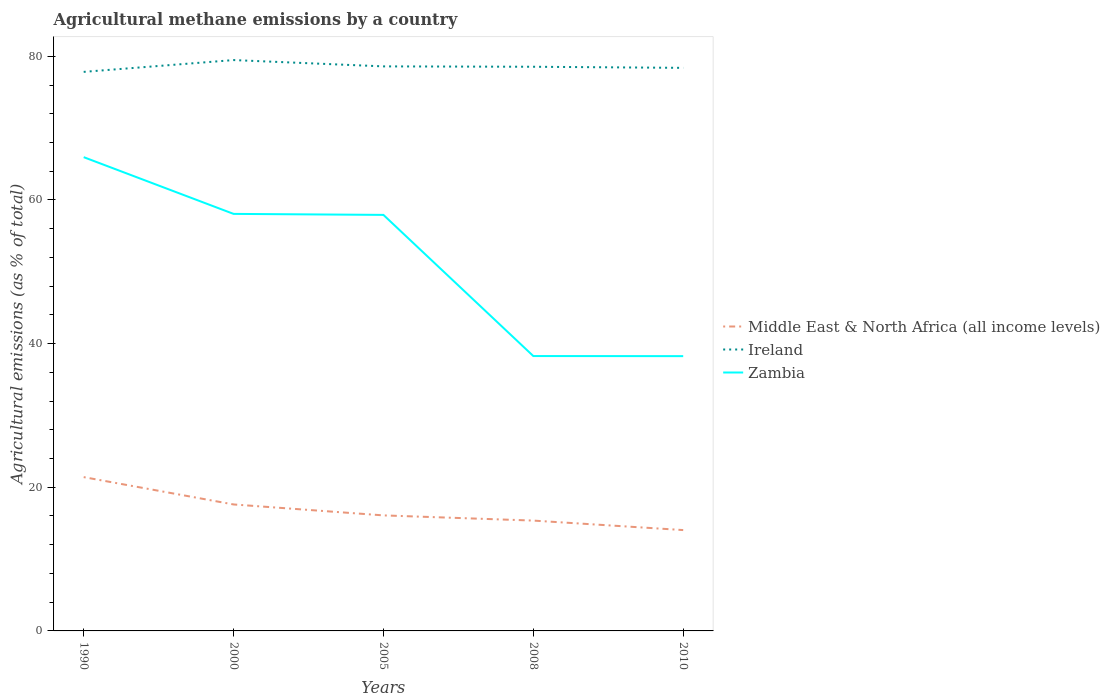How many different coloured lines are there?
Keep it short and to the point. 3. Does the line corresponding to Middle East & North Africa (all income levels) intersect with the line corresponding to Zambia?
Give a very brief answer. No. Is the number of lines equal to the number of legend labels?
Keep it short and to the point. Yes. Across all years, what is the maximum amount of agricultural methane emitted in Ireland?
Your answer should be compact. 77.83. What is the total amount of agricultural methane emitted in Middle East & North Africa (all income levels) in the graph?
Provide a succinct answer. 6.05. What is the difference between the highest and the second highest amount of agricultural methane emitted in Zambia?
Make the answer very short. 27.7. Are the values on the major ticks of Y-axis written in scientific E-notation?
Ensure brevity in your answer.  No. Does the graph contain any zero values?
Your answer should be very brief. No. How many legend labels are there?
Ensure brevity in your answer.  3. What is the title of the graph?
Provide a succinct answer. Agricultural methane emissions by a country. What is the label or title of the Y-axis?
Your answer should be compact. Agricultural emissions (as % of total). What is the Agricultural emissions (as % of total) of Middle East & North Africa (all income levels) in 1990?
Provide a short and direct response. 21.41. What is the Agricultural emissions (as % of total) of Ireland in 1990?
Keep it short and to the point. 77.83. What is the Agricultural emissions (as % of total) in Zambia in 1990?
Make the answer very short. 65.96. What is the Agricultural emissions (as % of total) in Middle East & North Africa (all income levels) in 2000?
Give a very brief answer. 17.61. What is the Agricultural emissions (as % of total) of Ireland in 2000?
Keep it short and to the point. 79.48. What is the Agricultural emissions (as % of total) of Zambia in 2000?
Give a very brief answer. 58.06. What is the Agricultural emissions (as % of total) of Middle East & North Africa (all income levels) in 2005?
Offer a very short reply. 16.09. What is the Agricultural emissions (as % of total) of Ireland in 2005?
Your answer should be very brief. 78.6. What is the Agricultural emissions (as % of total) of Zambia in 2005?
Ensure brevity in your answer.  57.92. What is the Agricultural emissions (as % of total) in Middle East & North Africa (all income levels) in 2008?
Ensure brevity in your answer.  15.36. What is the Agricultural emissions (as % of total) of Ireland in 2008?
Offer a terse response. 78.55. What is the Agricultural emissions (as % of total) of Zambia in 2008?
Your answer should be very brief. 38.27. What is the Agricultural emissions (as % of total) in Middle East & North Africa (all income levels) in 2010?
Your answer should be compact. 14.04. What is the Agricultural emissions (as % of total) of Ireland in 2010?
Make the answer very short. 78.39. What is the Agricultural emissions (as % of total) in Zambia in 2010?
Keep it short and to the point. 38.26. Across all years, what is the maximum Agricultural emissions (as % of total) in Middle East & North Africa (all income levels)?
Your answer should be very brief. 21.41. Across all years, what is the maximum Agricultural emissions (as % of total) of Ireland?
Your answer should be compact. 79.48. Across all years, what is the maximum Agricultural emissions (as % of total) of Zambia?
Offer a terse response. 65.96. Across all years, what is the minimum Agricultural emissions (as % of total) of Middle East & North Africa (all income levels)?
Provide a short and direct response. 14.04. Across all years, what is the minimum Agricultural emissions (as % of total) of Ireland?
Make the answer very short. 77.83. Across all years, what is the minimum Agricultural emissions (as % of total) in Zambia?
Your answer should be compact. 38.26. What is the total Agricultural emissions (as % of total) in Middle East & North Africa (all income levels) in the graph?
Provide a short and direct response. 84.51. What is the total Agricultural emissions (as % of total) of Ireland in the graph?
Provide a succinct answer. 392.85. What is the total Agricultural emissions (as % of total) of Zambia in the graph?
Offer a terse response. 258.47. What is the difference between the Agricultural emissions (as % of total) of Middle East & North Africa (all income levels) in 1990 and that in 2000?
Keep it short and to the point. 3.81. What is the difference between the Agricultural emissions (as % of total) in Ireland in 1990 and that in 2000?
Offer a very short reply. -1.64. What is the difference between the Agricultural emissions (as % of total) of Zambia in 1990 and that in 2000?
Keep it short and to the point. 7.9. What is the difference between the Agricultural emissions (as % of total) of Middle East & North Africa (all income levels) in 1990 and that in 2005?
Your answer should be very brief. 5.33. What is the difference between the Agricultural emissions (as % of total) in Ireland in 1990 and that in 2005?
Your answer should be very brief. -0.76. What is the difference between the Agricultural emissions (as % of total) of Zambia in 1990 and that in 2005?
Keep it short and to the point. 8.04. What is the difference between the Agricultural emissions (as % of total) of Middle East & North Africa (all income levels) in 1990 and that in 2008?
Provide a short and direct response. 6.05. What is the difference between the Agricultural emissions (as % of total) of Ireland in 1990 and that in 2008?
Provide a short and direct response. -0.71. What is the difference between the Agricultural emissions (as % of total) of Zambia in 1990 and that in 2008?
Offer a very short reply. 27.69. What is the difference between the Agricultural emissions (as % of total) in Middle East & North Africa (all income levels) in 1990 and that in 2010?
Your answer should be very brief. 7.37. What is the difference between the Agricultural emissions (as % of total) in Ireland in 1990 and that in 2010?
Provide a succinct answer. -0.56. What is the difference between the Agricultural emissions (as % of total) in Zambia in 1990 and that in 2010?
Make the answer very short. 27.7. What is the difference between the Agricultural emissions (as % of total) in Middle East & North Africa (all income levels) in 2000 and that in 2005?
Give a very brief answer. 1.52. What is the difference between the Agricultural emissions (as % of total) of Ireland in 2000 and that in 2005?
Offer a very short reply. 0.88. What is the difference between the Agricultural emissions (as % of total) of Zambia in 2000 and that in 2005?
Offer a very short reply. 0.14. What is the difference between the Agricultural emissions (as % of total) in Middle East & North Africa (all income levels) in 2000 and that in 2008?
Provide a short and direct response. 2.25. What is the difference between the Agricultural emissions (as % of total) in Ireland in 2000 and that in 2008?
Your answer should be compact. 0.93. What is the difference between the Agricultural emissions (as % of total) in Zambia in 2000 and that in 2008?
Your answer should be very brief. 19.79. What is the difference between the Agricultural emissions (as % of total) of Middle East & North Africa (all income levels) in 2000 and that in 2010?
Offer a terse response. 3.57. What is the difference between the Agricultural emissions (as % of total) of Ireland in 2000 and that in 2010?
Your answer should be compact. 1.08. What is the difference between the Agricultural emissions (as % of total) of Zambia in 2000 and that in 2010?
Your answer should be compact. 19.8. What is the difference between the Agricultural emissions (as % of total) in Middle East & North Africa (all income levels) in 2005 and that in 2008?
Your answer should be compact. 0.72. What is the difference between the Agricultural emissions (as % of total) in Ireland in 2005 and that in 2008?
Your answer should be compact. 0.05. What is the difference between the Agricultural emissions (as % of total) in Zambia in 2005 and that in 2008?
Keep it short and to the point. 19.65. What is the difference between the Agricultural emissions (as % of total) in Middle East & North Africa (all income levels) in 2005 and that in 2010?
Provide a short and direct response. 2.05. What is the difference between the Agricultural emissions (as % of total) in Ireland in 2005 and that in 2010?
Provide a succinct answer. 0.21. What is the difference between the Agricultural emissions (as % of total) in Zambia in 2005 and that in 2010?
Keep it short and to the point. 19.66. What is the difference between the Agricultural emissions (as % of total) of Middle East & North Africa (all income levels) in 2008 and that in 2010?
Make the answer very short. 1.32. What is the difference between the Agricultural emissions (as % of total) in Ireland in 2008 and that in 2010?
Give a very brief answer. 0.15. What is the difference between the Agricultural emissions (as % of total) of Zambia in 2008 and that in 2010?
Offer a terse response. 0.01. What is the difference between the Agricultural emissions (as % of total) in Middle East & North Africa (all income levels) in 1990 and the Agricultural emissions (as % of total) in Ireland in 2000?
Your answer should be compact. -58.06. What is the difference between the Agricultural emissions (as % of total) of Middle East & North Africa (all income levels) in 1990 and the Agricultural emissions (as % of total) of Zambia in 2000?
Offer a very short reply. -36.65. What is the difference between the Agricultural emissions (as % of total) of Ireland in 1990 and the Agricultural emissions (as % of total) of Zambia in 2000?
Your answer should be compact. 19.77. What is the difference between the Agricultural emissions (as % of total) in Middle East & North Africa (all income levels) in 1990 and the Agricultural emissions (as % of total) in Ireland in 2005?
Ensure brevity in your answer.  -57.19. What is the difference between the Agricultural emissions (as % of total) in Middle East & North Africa (all income levels) in 1990 and the Agricultural emissions (as % of total) in Zambia in 2005?
Provide a succinct answer. -36.51. What is the difference between the Agricultural emissions (as % of total) in Ireland in 1990 and the Agricultural emissions (as % of total) in Zambia in 2005?
Give a very brief answer. 19.91. What is the difference between the Agricultural emissions (as % of total) in Middle East & North Africa (all income levels) in 1990 and the Agricultural emissions (as % of total) in Ireland in 2008?
Offer a very short reply. -57.13. What is the difference between the Agricultural emissions (as % of total) in Middle East & North Africa (all income levels) in 1990 and the Agricultural emissions (as % of total) in Zambia in 2008?
Provide a succinct answer. -16.86. What is the difference between the Agricultural emissions (as % of total) of Ireland in 1990 and the Agricultural emissions (as % of total) of Zambia in 2008?
Make the answer very short. 39.57. What is the difference between the Agricultural emissions (as % of total) of Middle East & North Africa (all income levels) in 1990 and the Agricultural emissions (as % of total) of Ireland in 2010?
Your answer should be very brief. -56.98. What is the difference between the Agricultural emissions (as % of total) in Middle East & North Africa (all income levels) in 1990 and the Agricultural emissions (as % of total) in Zambia in 2010?
Make the answer very short. -16.84. What is the difference between the Agricultural emissions (as % of total) in Ireland in 1990 and the Agricultural emissions (as % of total) in Zambia in 2010?
Provide a succinct answer. 39.58. What is the difference between the Agricultural emissions (as % of total) of Middle East & North Africa (all income levels) in 2000 and the Agricultural emissions (as % of total) of Ireland in 2005?
Offer a very short reply. -60.99. What is the difference between the Agricultural emissions (as % of total) in Middle East & North Africa (all income levels) in 2000 and the Agricultural emissions (as % of total) in Zambia in 2005?
Give a very brief answer. -40.31. What is the difference between the Agricultural emissions (as % of total) of Ireland in 2000 and the Agricultural emissions (as % of total) of Zambia in 2005?
Offer a terse response. 21.55. What is the difference between the Agricultural emissions (as % of total) of Middle East & North Africa (all income levels) in 2000 and the Agricultural emissions (as % of total) of Ireland in 2008?
Offer a very short reply. -60.94. What is the difference between the Agricultural emissions (as % of total) of Middle East & North Africa (all income levels) in 2000 and the Agricultural emissions (as % of total) of Zambia in 2008?
Give a very brief answer. -20.66. What is the difference between the Agricultural emissions (as % of total) in Ireland in 2000 and the Agricultural emissions (as % of total) in Zambia in 2008?
Make the answer very short. 41.21. What is the difference between the Agricultural emissions (as % of total) in Middle East & North Africa (all income levels) in 2000 and the Agricultural emissions (as % of total) in Ireland in 2010?
Offer a terse response. -60.78. What is the difference between the Agricultural emissions (as % of total) in Middle East & North Africa (all income levels) in 2000 and the Agricultural emissions (as % of total) in Zambia in 2010?
Your answer should be very brief. -20.65. What is the difference between the Agricultural emissions (as % of total) of Ireland in 2000 and the Agricultural emissions (as % of total) of Zambia in 2010?
Your response must be concise. 41.22. What is the difference between the Agricultural emissions (as % of total) of Middle East & North Africa (all income levels) in 2005 and the Agricultural emissions (as % of total) of Ireland in 2008?
Your answer should be very brief. -62.46. What is the difference between the Agricultural emissions (as % of total) of Middle East & North Africa (all income levels) in 2005 and the Agricultural emissions (as % of total) of Zambia in 2008?
Provide a short and direct response. -22.18. What is the difference between the Agricultural emissions (as % of total) in Ireland in 2005 and the Agricultural emissions (as % of total) in Zambia in 2008?
Offer a very short reply. 40.33. What is the difference between the Agricultural emissions (as % of total) of Middle East & North Africa (all income levels) in 2005 and the Agricultural emissions (as % of total) of Ireland in 2010?
Provide a succinct answer. -62.31. What is the difference between the Agricultural emissions (as % of total) in Middle East & North Africa (all income levels) in 2005 and the Agricultural emissions (as % of total) in Zambia in 2010?
Provide a succinct answer. -22.17. What is the difference between the Agricultural emissions (as % of total) of Ireland in 2005 and the Agricultural emissions (as % of total) of Zambia in 2010?
Make the answer very short. 40.34. What is the difference between the Agricultural emissions (as % of total) of Middle East & North Africa (all income levels) in 2008 and the Agricultural emissions (as % of total) of Ireland in 2010?
Provide a short and direct response. -63.03. What is the difference between the Agricultural emissions (as % of total) in Middle East & North Africa (all income levels) in 2008 and the Agricultural emissions (as % of total) in Zambia in 2010?
Give a very brief answer. -22.9. What is the difference between the Agricultural emissions (as % of total) in Ireland in 2008 and the Agricultural emissions (as % of total) in Zambia in 2010?
Your answer should be compact. 40.29. What is the average Agricultural emissions (as % of total) in Middle East & North Africa (all income levels) per year?
Keep it short and to the point. 16.9. What is the average Agricultural emissions (as % of total) of Ireland per year?
Provide a succinct answer. 78.57. What is the average Agricultural emissions (as % of total) of Zambia per year?
Your answer should be very brief. 51.69. In the year 1990, what is the difference between the Agricultural emissions (as % of total) in Middle East & North Africa (all income levels) and Agricultural emissions (as % of total) in Ireland?
Provide a short and direct response. -56.42. In the year 1990, what is the difference between the Agricultural emissions (as % of total) in Middle East & North Africa (all income levels) and Agricultural emissions (as % of total) in Zambia?
Your answer should be very brief. -44.55. In the year 1990, what is the difference between the Agricultural emissions (as % of total) of Ireland and Agricultural emissions (as % of total) of Zambia?
Your response must be concise. 11.87. In the year 2000, what is the difference between the Agricultural emissions (as % of total) in Middle East & North Africa (all income levels) and Agricultural emissions (as % of total) in Ireland?
Your response must be concise. -61.87. In the year 2000, what is the difference between the Agricultural emissions (as % of total) in Middle East & North Africa (all income levels) and Agricultural emissions (as % of total) in Zambia?
Provide a succinct answer. -40.45. In the year 2000, what is the difference between the Agricultural emissions (as % of total) of Ireland and Agricultural emissions (as % of total) of Zambia?
Your answer should be compact. 21.42. In the year 2005, what is the difference between the Agricultural emissions (as % of total) of Middle East & North Africa (all income levels) and Agricultural emissions (as % of total) of Ireland?
Your answer should be compact. -62.51. In the year 2005, what is the difference between the Agricultural emissions (as % of total) of Middle East & North Africa (all income levels) and Agricultural emissions (as % of total) of Zambia?
Your response must be concise. -41.84. In the year 2005, what is the difference between the Agricultural emissions (as % of total) of Ireland and Agricultural emissions (as % of total) of Zambia?
Provide a short and direct response. 20.68. In the year 2008, what is the difference between the Agricultural emissions (as % of total) of Middle East & North Africa (all income levels) and Agricultural emissions (as % of total) of Ireland?
Make the answer very short. -63.18. In the year 2008, what is the difference between the Agricultural emissions (as % of total) in Middle East & North Africa (all income levels) and Agricultural emissions (as % of total) in Zambia?
Give a very brief answer. -22.91. In the year 2008, what is the difference between the Agricultural emissions (as % of total) of Ireland and Agricultural emissions (as % of total) of Zambia?
Your response must be concise. 40.28. In the year 2010, what is the difference between the Agricultural emissions (as % of total) in Middle East & North Africa (all income levels) and Agricultural emissions (as % of total) in Ireland?
Your answer should be very brief. -64.35. In the year 2010, what is the difference between the Agricultural emissions (as % of total) in Middle East & North Africa (all income levels) and Agricultural emissions (as % of total) in Zambia?
Your answer should be very brief. -24.22. In the year 2010, what is the difference between the Agricultural emissions (as % of total) of Ireland and Agricultural emissions (as % of total) of Zambia?
Offer a very short reply. 40.14. What is the ratio of the Agricultural emissions (as % of total) of Middle East & North Africa (all income levels) in 1990 to that in 2000?
Your answer should be very brief. 1.22. What is the ratio of the Agricultural emissions (as % of total) of Ireland in 1990 to that in 2000?
Offer a terse response. 0.98. What is the ratio of the Agricultural emissions (as % of total) of Zambia in 1990 to that in 2000?
Provide a short and direct response. 1.14. What is the ratio of the Agricultural emissions (as % of total) in Middle East & North Africa (all income levels) in 1990 to that in 2005?
Make the answer very short. 1.33. What is the ratio of the Agricultural emissions (as % of total) in Ireland in 1990 to that in 2005?
Offer a terse response. 0.99. What is the ratio of the Agricultural emissions (as % of total) of Zambia in 1990 to that in 2005?
Your response must be concise. 1.14. What is the ratio of the Agricultural emissions (as % of total) in Middle East & North Africa (all income levels) in 1990 to that in 2008?
Your answer should be very brief. 1.39. What is the ratio of the Agricultural emissions (as % of total) of Ireland in 1990 to that in 2008?
Provide a succinct answer. 0.99. What is the ratio of the Agricultural emissions (as % of total) in Zambia in 1990 to that in 2008?
Offer a very short reply. 1.72. What is the ratio of the Agricultural emissions (as % of total) of Middle East & North Africa (all income levels) in 1990 to that in 2010?
Ensure brevity in your answer.  1.53. What is the ratio of the Agricultural emissions (as % of total) in Ireland in 1990 to that in 2010?
Give a very brief answer. 0.99. What is the ratio of the Agricultural emissions (as % of total) in Zambia in 1990 to that in 2010?
Your answer should be very brief. 1.72. What is the ratio of the Agricultural emissions (as % of total) in Middle East & North Africa (all income levels) in 2000 to that in 2005?
Keep it short and to the point. 1.09. What is the ratio of the Agricultural emissions (as % of total) in Ireland in 2000 to that in 2005?
Provide a short and direct response. 1.01. What is the ratio of the Agricultural emissions (as % of total) in Middle East & North Africa (all income levels) in 2000 to that in 2008?
Your answer should be compact. 1.15. What is the ratio of the Agricultural emissions (as % of total) in Ireland in 2000 to that in 2008?
Offer a very short reply. 1.01. What is the ratio of the Agricultural emissions (as % of total) of Zambia in 2000 to that in 2008?
Your response must be concise. 1.52. What is the ratio of the Agricultural emissions (as % of total) in Middle East & North Africa (all income levels) in 2000 to that in 2010?
Ensure brevity in your answer.  1.25. What is the ratio of the Agricultural emissions (as % of total) in Ireland in 2000 to that in 2010?
Make the answer very short. 1.01. What is the ratio of the Agricultural emissions (as % of total) of Zambia in 2000 to that in 2010?
Offer a very short reply. 1.52. What is the ratio of the Agricultural emissions (as % of total) in Middle East & North Africa (all income levels) in 2005 to that in 2008?
Keep it short and to the point. 1.05. What is the ratio of the Agricultural emissions (as % of total) in Ireland in 2005 to that in 2008?
Your response must be concise. 1. What is the ratio of the Agricultural emissions (as % of total) of Zambia in 2005 to that in 2008?
Provide a short and direct response. 1.51. What is the ratio of the Agricultural emissions (as % of total) of Middle East & North Africa (all income levels) in 2005 to that in 2010?
Provide a short and direct response. 1.15. What is the ratio of the Agricultural emissions (as % of total) in Zambia in 2005 to that in 2010?
Ensure brevity in your answer.  1.51. What is the ratio of the Agricultural emissions (as % of total) in Middle East & North Africa (all income levels) in 2008 to that in 2010?
Your answer should be very brief. 1.09. What is the difference between the highest and the second highest Agricultural emissions (as % of total) in Middle East & North Africa (all income levels)?
Make the answer very short. 3.81. What is the difference between the highest and the second highest Agricultural emissions (as % of total) in Ireland?
Your answer should be compact. 0.88. What is the difference between the highest and the second highest Agricultural emissions (as % of total) of Zambia?
Your answer should be compact. 7.9. What is the difference between the highest and the lowest Agricultural emissions (as % of total) in Middle East & North Africa (all income levels)?
Your answer should be very brief. 7.37. What is the difference between the highest and the lowest Agricultural emissions (as % of total) in Ireland?
Offer a very short reply. 1.64. What is the difference between the highest and the lowest Agricultural emissions (as % of total) in Zambia?
Give a very brief answer. 27.7. 